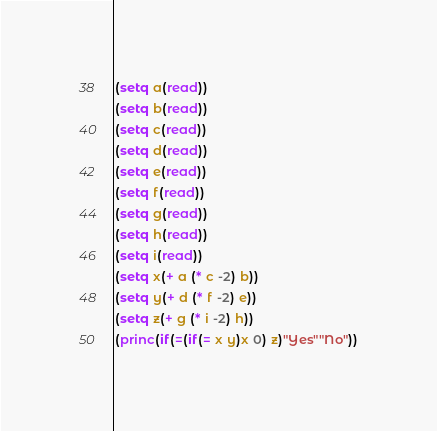Convert code to text. <code><loc_0><loc_0><loc_500><loc_500><_Lisp_>(setq a(read))
(setq b(read))
(setq c(read))
(setq d(read))
(setq e(read))
(setq f(read))
(setq g(read))
(setq h(read))
(setq i(read))
(setq x(+ a (* c -2) b))
(setq y(+ d (* f -2) e))
(setq z(+ g (* i -2) h))
(princ(if(=(if(= x y)x 0) z)"Yes""No"))</code> 